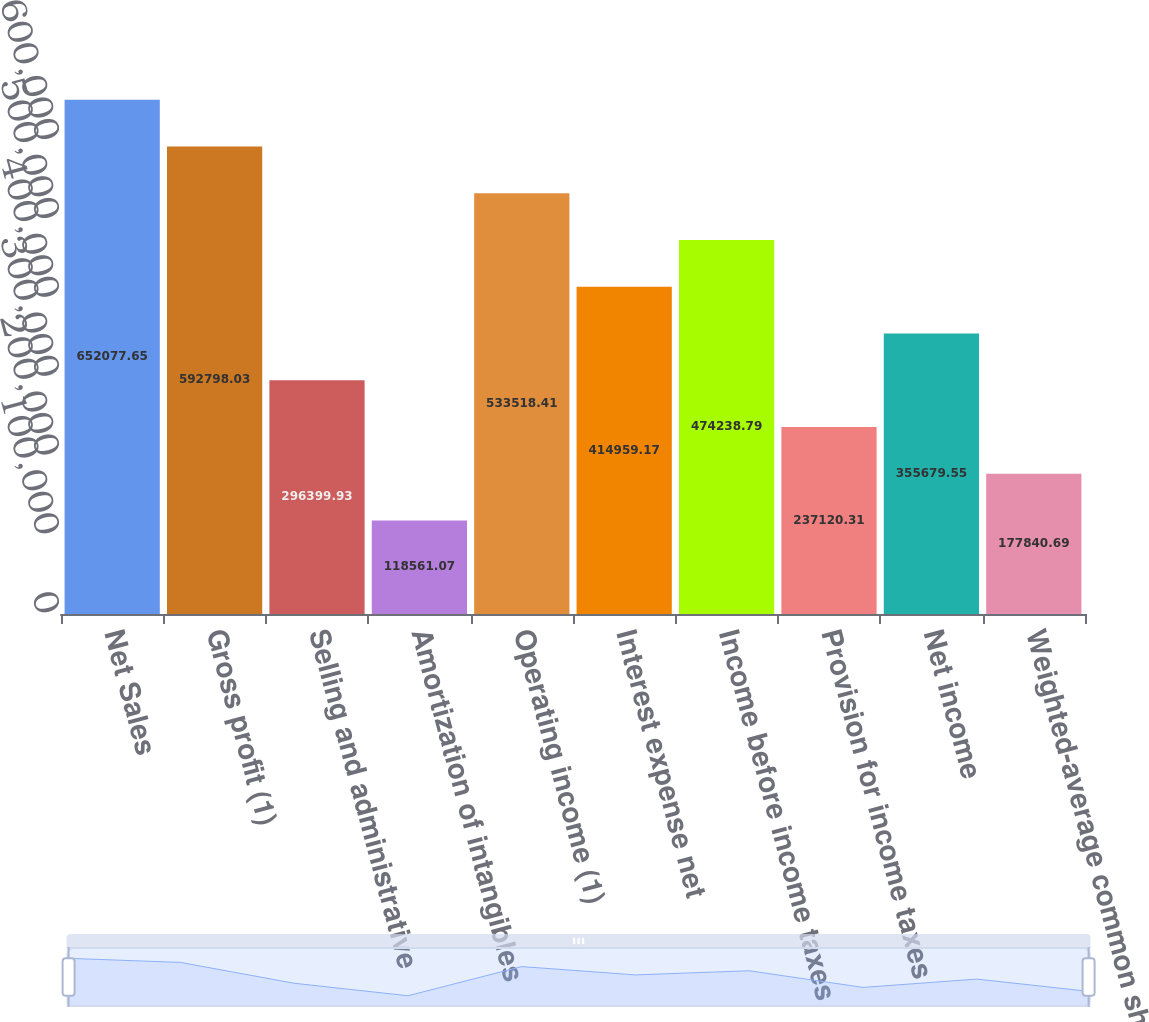Convert chart. <chart><loc_0><loc_0><loc_500><loc_500><bar_chart><fcel>Net Sales<fcel>Gross profit (1)<fcel>Selling and administrative<fcel>Amortization of intangibles<fcel>Operating income (1)<fcel>Interest expense net<fcel>Income before income taxes<fcel>Provision for income taxes<fcel>Net income<fcel>Weighted-average common shares<nl><fcel>652078<fcel>592798<fcel>296400<fcel>118561<fcel>533518<fcel>414959<fcel>474239<fcel>237120<fcel>355680<fcel>177841<nl></chart> 